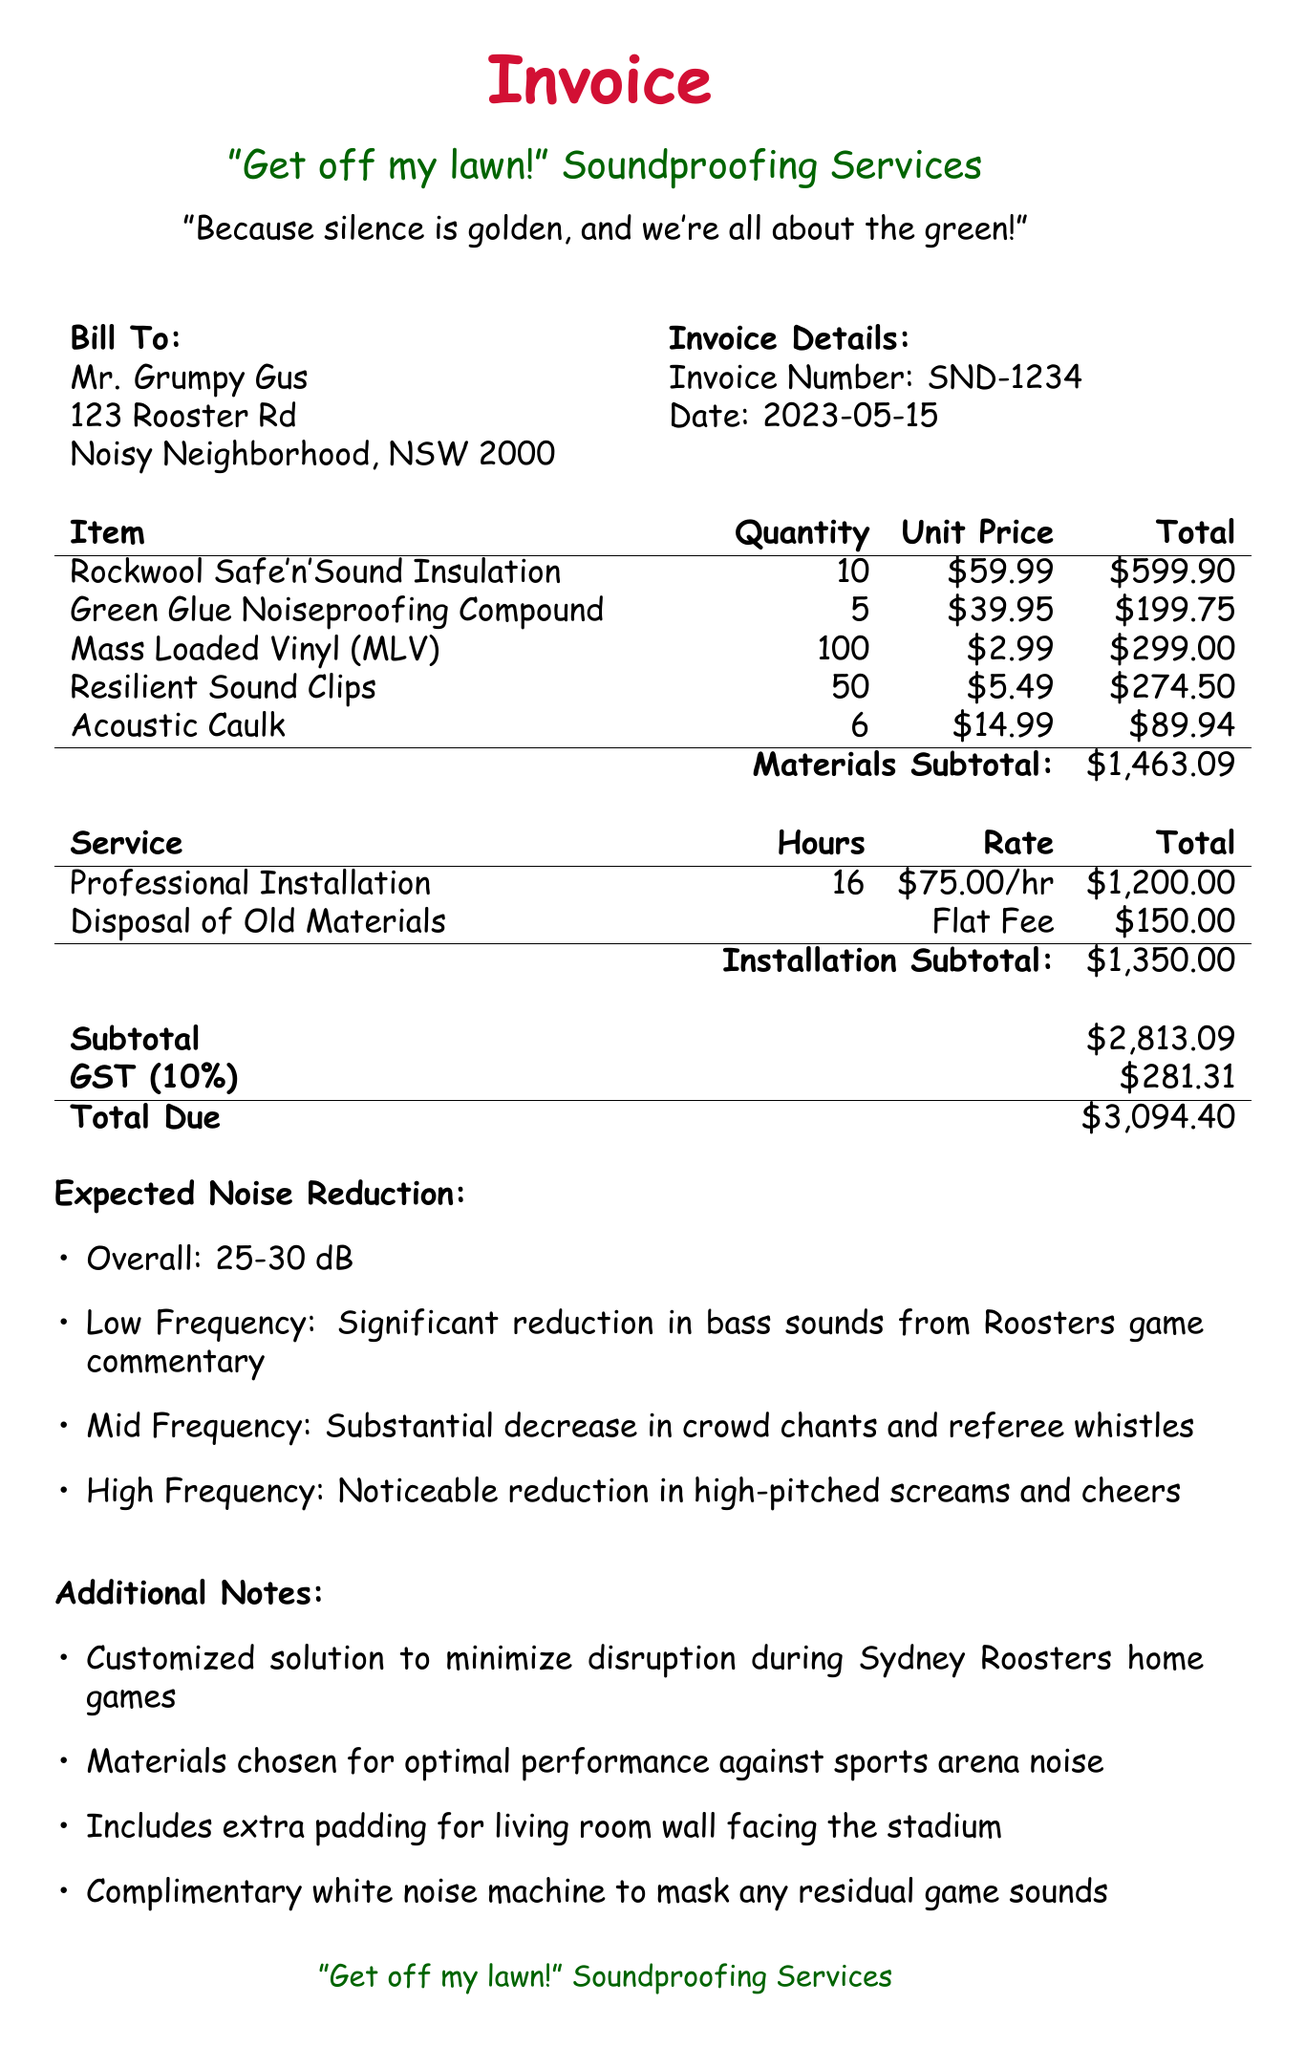what is the total cost of the invoice? The total cost is the sum of materials, installation, GST, which totals to $3094.40.
Answer: $3094.40 who is the customer? The customer's name is provided at the top of the invoice.
Answer: Mr. Grumpy Gus when was the invoice issued? The date can be found in the invoice details section.
Answer: 2023-05-15 how many units of Mass Loaded Vinyl were purchased? The quantity of Mass Loaded Vinyl is listed in the soundproofing materials section.
Answer: 100 what is the expected overall noise reduction? The overall noise reduction is mentioned in the expected noise reduction section.
Answer: 25-30 dB what is the flat fee for disposal of old materials? The disposal fee is indicated under installation costs.
Answer: $150.00 how many hours were billed for professional installation? The hours spent on professional installation are specified in the installation costs section.
Answer: 16 what item is used for filling gaps and cracks? The specific item for filling gaps is mentioned in the soundproofing materials section.
Answer: Acoustic Caulk what noise does the soundproofing help reduce significantly? The specific type of noise reduction is listed in the expected noise reduction section.
Answer: bass sounds from Roosters game commentary 